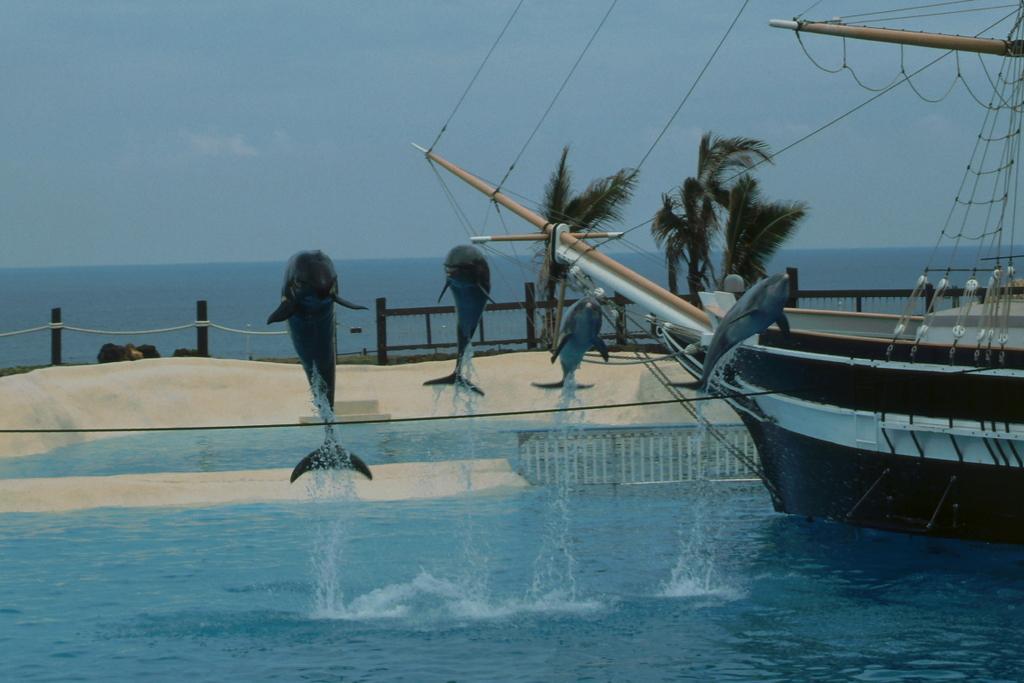Could you give a brief overview of what you see in this image? In the center of the image there are dolphins. At the bottom we can see water. On the right there is a ship on the water. In the background there is a fence, trees and sky. 